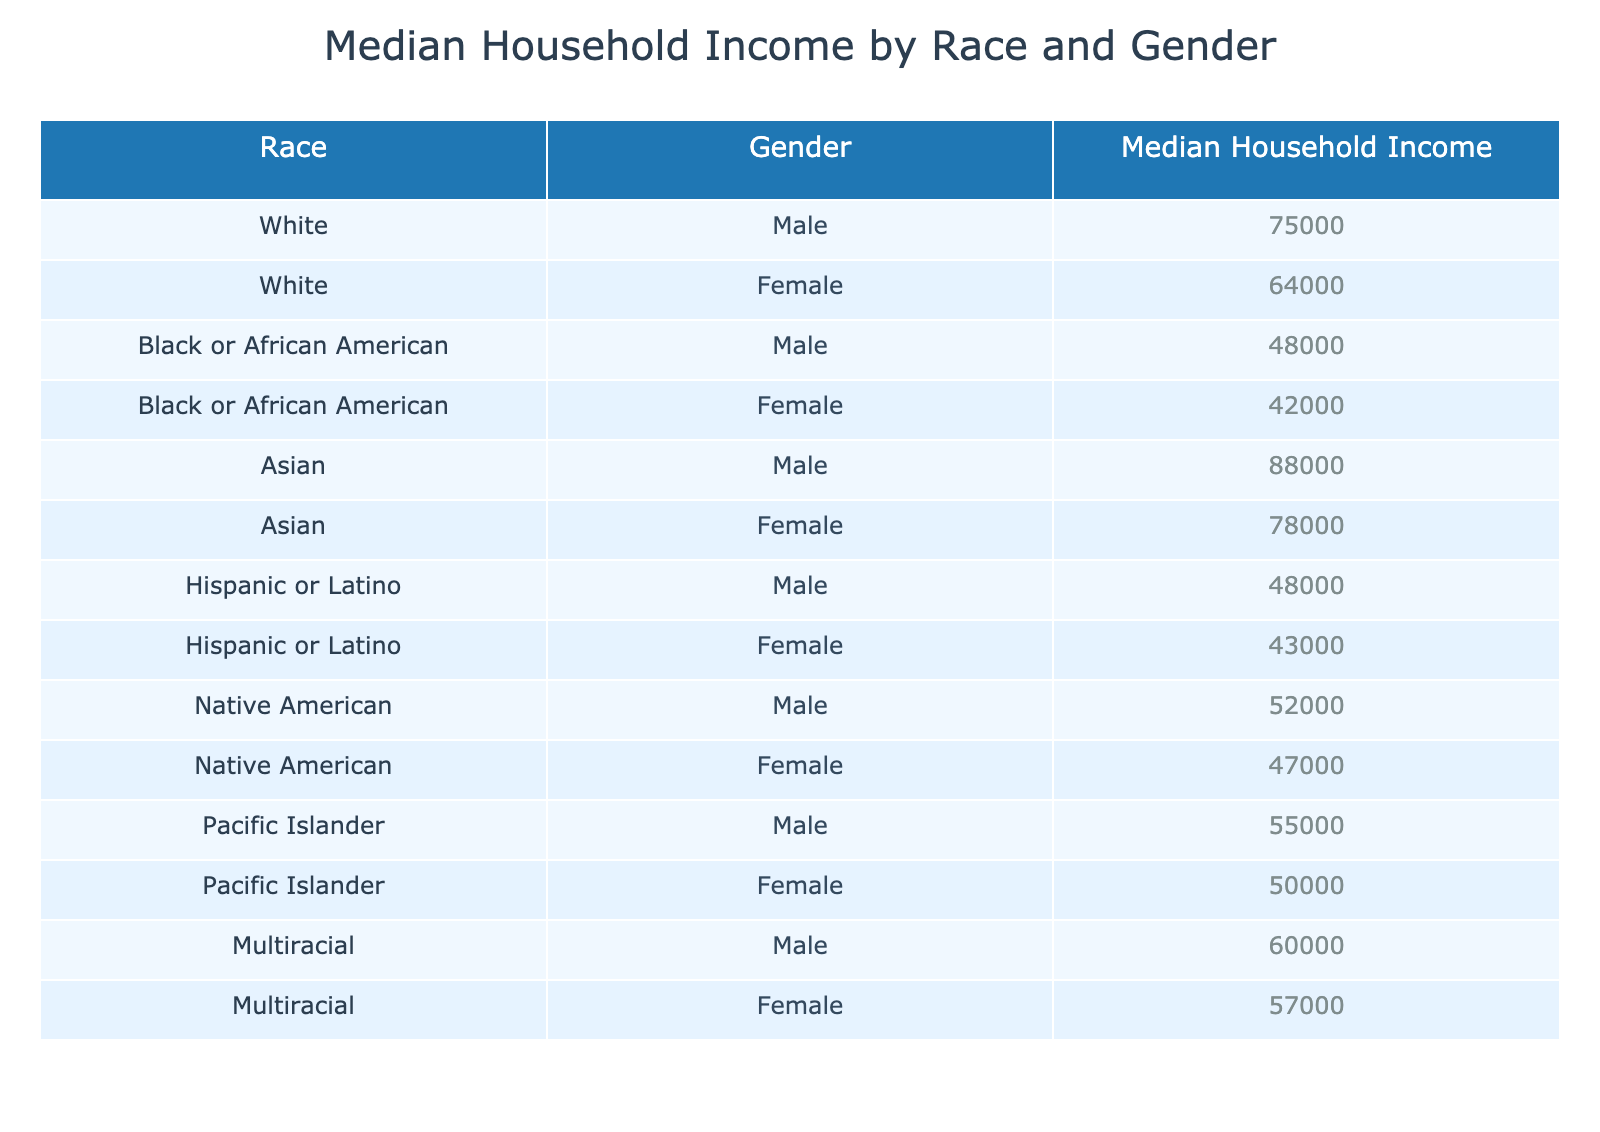What is the Median Household Income for White Females? Referring to the table, the income listed for White Females is directly stated.
Answer: 64000 What is the Median Household Income for Asian Males? The table shows that the income for Asian Males is specified.
Answer: 88000 Which gender has a higher Median Household Income between Black or African American Males and Females? By examining the incomes listed, Black or African American Males have an income of 48000 while Females have 42000; therefore, the Male income is higher.
Answer: Males What is the difference in Median Household Income between Asian Males and Hispanic or Latino Males? The income for Asian Males is 88000 and for Hispanic or Latino Males it is 48000. The difference is calculated as 88000 - 48000 = 40000.
Answer: 40000 Is the Median Household Income for Pacific Islander Males greater than that for Native American Females? The values for Pacific Islander Males is 55000, and for Native American Females it is 47000. Since 55000 is greater than 47000, the statement is true.
Answer: Yes What is the average Median Household Income for all Female groups? The Median Household Incomes for the female groups are summed as follows: White Female (64000), Black or African American Female (42000), Asian Female (78000), Hispanic or Latino Female (43000), Native American Female (47000), Pacific Islander Female (50000), and Multiracial Female (57000). The total income is 64000 + 42000 + 78000 + 43000 + 47000 + 50000 + 57000 = 351000. There are 7 groups, so the average is 351000 / 7 = 50142.857.
Answer: 50142.857 What is the Median Household Income for Multiracial Males compared to White Males? From the table, the income for Multiracial Males is 60000 and for White Males it is 75000. 75000 is greater than 60000. Therefore, White Males have a higher income.
Answer: Yes How many groups have a Median Household Income below 50000? The Income for the groups are checked: Black or African American Females (42000), Hispanic or Latino Males (48000), and Hispanic or Latino Females (43000). This shows there are 3 groups with an income below 50000.
Answer: 3 Which racial group has the highest Median Household Income for Females? Analyzing the incomes for Females only, the highest values are White Female (64000), Black or African American Female (42000), Asian Female (78000), Hispanic or Latino Female (43000), Native American Female (47000), Pacific Islander Female (50000), and Multiracial Female (57000). Asian Females earn 78000, which is the highest.
Answer: Asian Female 